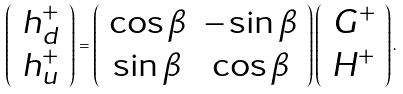<formula> <loc_0><loc_0><loc_500><loc_500>\left ( \begin{array} [ c ] { c } h _ { d } ^ { + } \\ h _ { u } ^ { + } \end{array} \right ) = \left ( \begin{array} [ c ] { c c } \cos \beta & - \sin \beta \\ \sin \beta & \cos \beta \end{array} \right ) \left ( \begin{array} [ c ] { c } G ^ { + } \\ H ^ { + } \end{array} \right ) .</formula> 